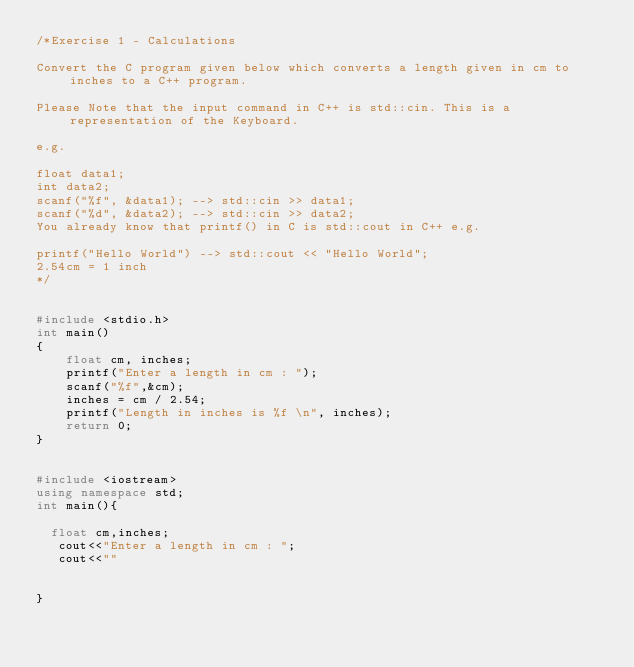Convert code to text. <code><loc_0><loc_0><loc_500><loc_500><_C++_>/*Exercise 1 - Calculations

Convert the C program given below which converts a length given in cm to inches to a C++ program.

Please Note that the input command in C++ is std::cin. This is a representation of the Keyboard.

e.g.

float data1;
int data2;
scanf("%f", &data1); --> std::cin >> data1;
scanf("%d", &data2); --> std::cin >> data2; 
You already know that printf() in C is std::cout in C++ e.g.

printf("Hello World") --> std::cout << "Hello World";
2.54cm = 1 inch
*/


#include <stdio.h>
int main() 
{
    float cm, inches;
    printf("Enter a length in cm : ");
    scanf("%f",&cm);
    inches = cm / 2.54;
    printf("Length in inches is %f \n", inches);
    return 0;
}  


#include <iostream>
using namespace std;
int main(){

  float cm,inches;
   cout<<"Enter a length in cm : ";
   cout<<""


}</code> 